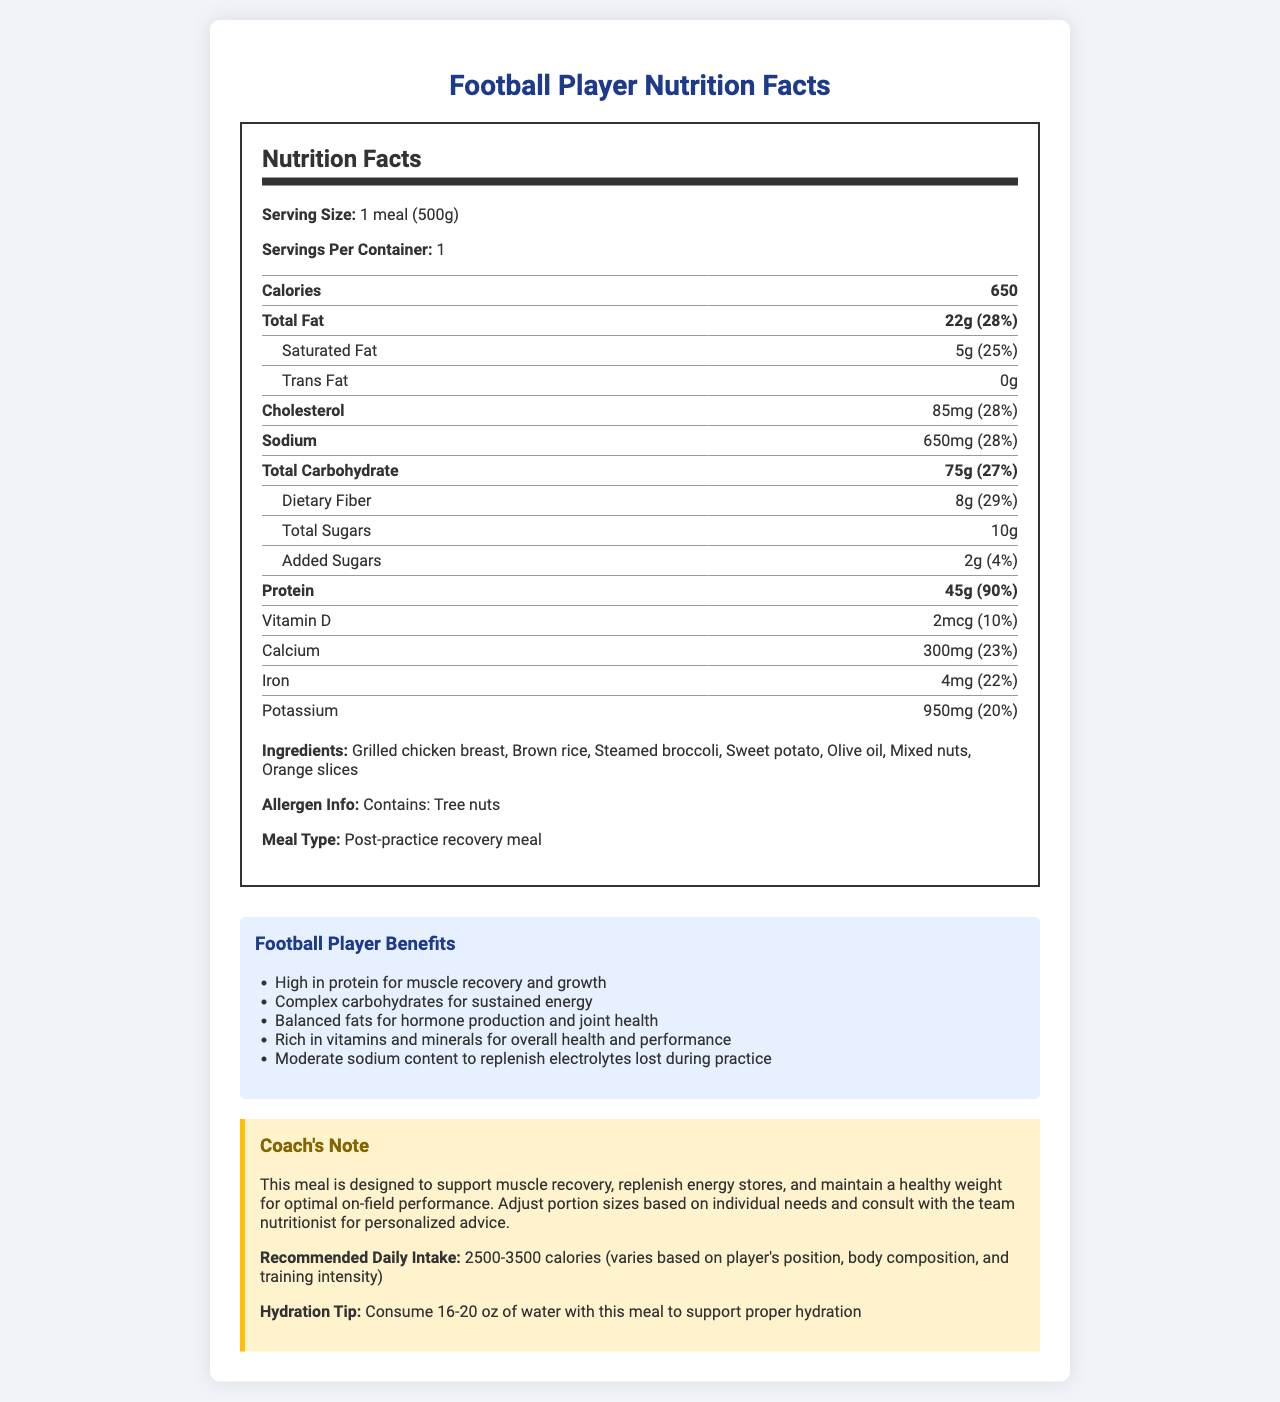what is the serving size of this meal? The serving size section clearly states "1 meal (500g)".
Answer: 1 meal (500g) how many calories are in one serving? The calories section shows that each serving contains 650 calories.
Answer: 650 how much protein does this meal provide? The protein section lists the amount as 45g, with a daily value of 90%.
Answer: 45g what is the daily value percentage of dietary fiber in this meal? The dietary fiber section under total carbohydrate states the daily value as 29%.
Answer: 29% which ingredient in this meal could cause a tree nut allergy? The allergen info section states "Contains: Tree nuts," and mixed nuts are listed as an ingredient.
Answer: Mixed nuts what is the total amount of sugar in this meal? A. 8g B. 2g C. 10g D. 75g The total sugar section under total carbohydrate shows an amount of 10g, which includes 2g of added sugars.
Answer: C. 10g how much sodium does this meal contain? A. 28% B. 85mg C. 750mg D. 650mg The sodium section lists the amount as 650mg with a daily value of 28%.
Answer: D. 650mg is this meal considered a pre-practice energy booster? The meal type section specifies that it is a "Post-practice recovery meal".
Answer: No summarize the main benefits of this meal for football players. The benefits section lists several advantages for football players, including high protein, complex carbs, balanced fats, rich vitamins and minerals, and moderate sodium content.
Answer: High protein for muscle recovery, complex carbs for energy, balanced fats for hormones and joints, vitamins and minerals for health, moderate sodium for electrolyte replenishment what is the specific daily value percentage for Vitamin D in this meal? The Vitamin D section shows that it provides 2mcg, which is 10% of the daily value.
Answer: 10% what should the hydration recommendation be with this meal? The hydration tip section recommends consuming 16-20 oz of water with this meal.
Answer: Consume 16-20 oz of water how much added sugar is in this meal? The total carbohydrate section under added sugars lists the amount as 2g with a daily value of 4%.
Answer: 2g describe the main idea of this document. The document includes detailed nutrition information, ingredients, benefits for athletes, and additional notes for coaches and players.
Answer: The document outlines the nutrition facts and benefits of a post-practice recovery meal for football players, highlighting its high protein content, complex carbohydrates, balanced fats, and essential vitamins and minerals to support recovery and performance. how much zinc is in this meal? The additional nutrients section lists zinc with an amount of 5mg and a daily value of 45%.
Answer: 5mg how many servings are there per container? The document states "Servings Per Container: 1" under the serving size information.
Answer: 1 are there any vitamins or minerals below 20% daily value in this meal? Both Vitamin D (10%) and Potassium (20%) are listed with daily values below 20%.
Answer: Yes how much cholesterol does this meal contain? The cholesterol section states the amount as 85mg with a daily value of 28%.
Answer: 85mg is carbohydrate content mainly from sugars? The meal has 75g of carbohydrates, but only 10g are sugars, indicating that most carbohydrates come from other sources such as dietary fiber (8g).
Answer: No 